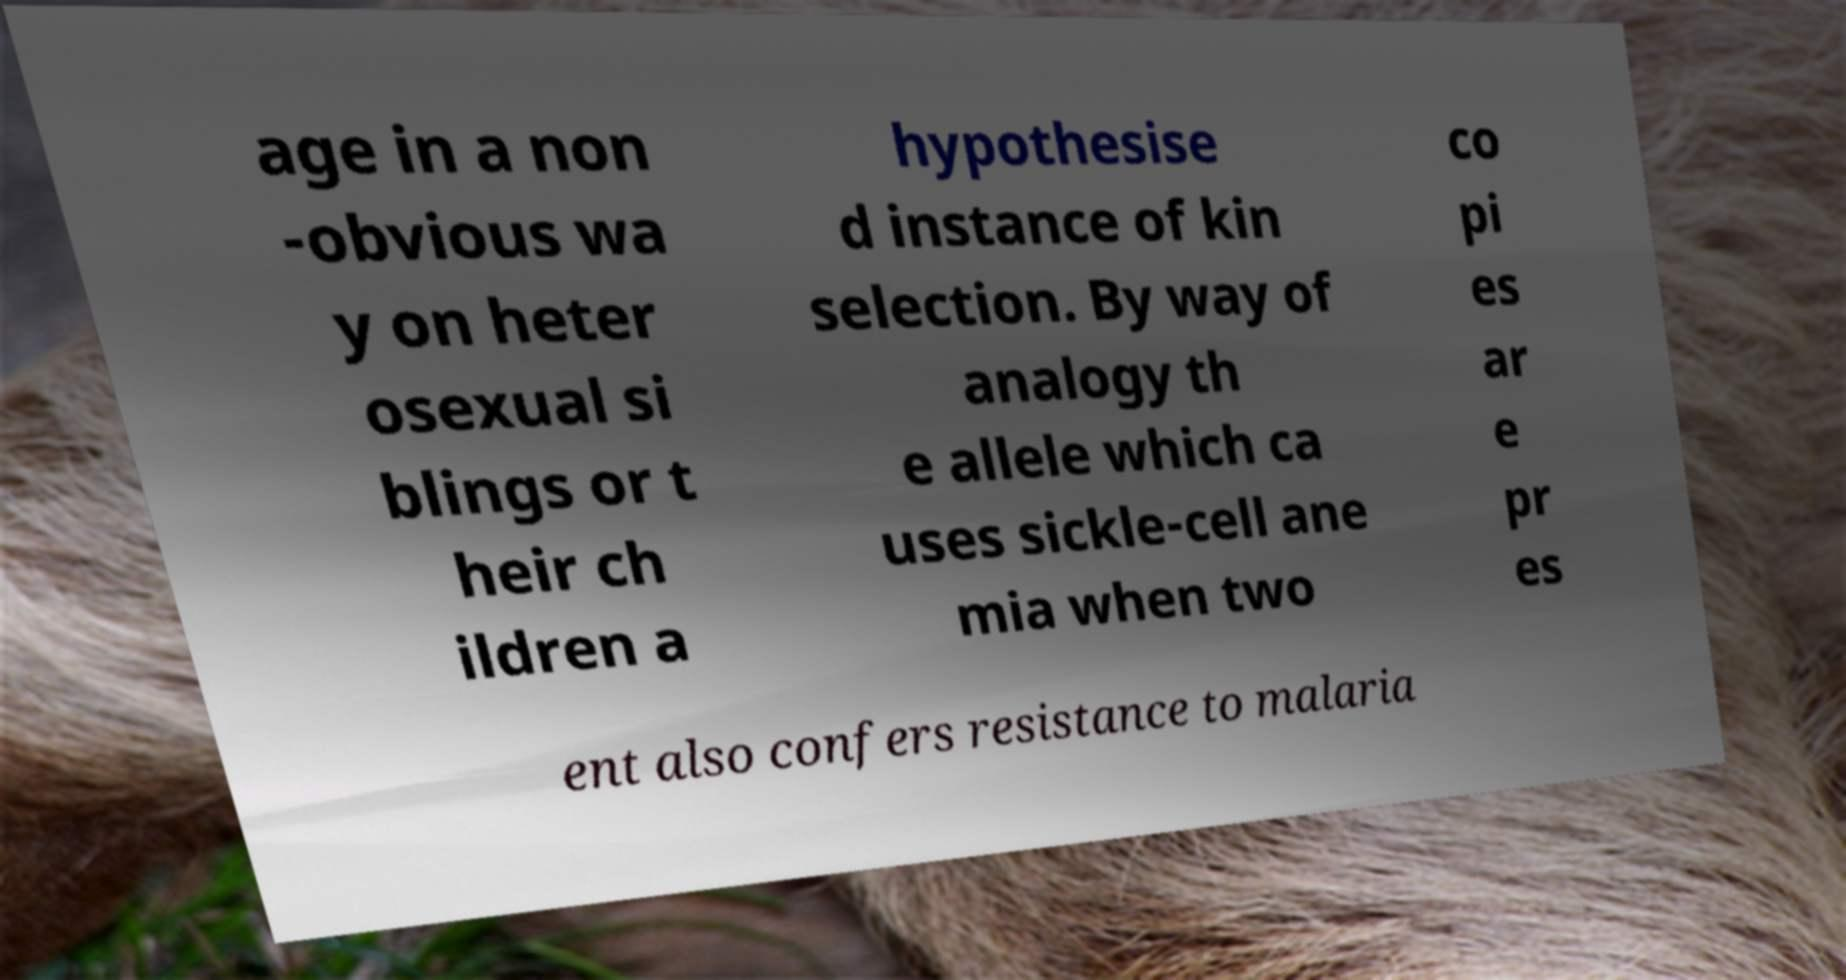Could you assist in decoding the text presented in this image and type it out clearly? age in a non -obvious wa y on heter osexual si blings or t heir ch ildren a hypothesise d instance of kin selection. By way of analogy th e allele which ca uses sickle-cell ane mia when two co pi es ar e pr es ent also confers resistance to malaria 